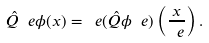<formula> <loc_0><loc_0><loc_500><loc_500>\hat { Q } _ { \ } e \phi ( x ) = \ e ( \hat { Q } \phi _ { \ } e ) \left ( \frac { x } { \ e } \right ) .</formula> 